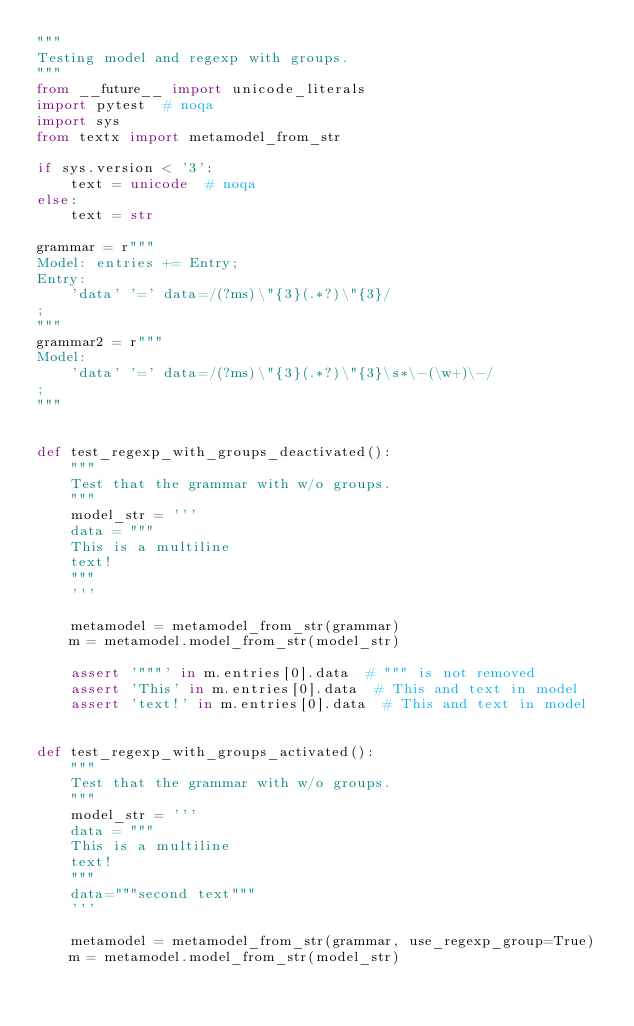Convert code to text. <code><loc_0><loc_0><loc_500><loc_500><_Python_>"""
Testing model and regexp with groups.
"""
from __future__ import unicode_literals
import pytest  # noqa
import sys
from textx import metamodel_from_str

if sys.version < '3':
    text = unicode  # noqa
else:
    text = str

grammar = r"""
Model: entries += Entry;
Entry:
    'data' '=' data=/(?ms)\"{3}(.*?)\"{3}/
;
"""
grammar2 = r"""
Model:
    'data' '=' data=/(?ms)\"{3}(.*?)\"{3}\s*\-(\w+)\-/
;
"""


def test_regexp_with_groups_deactivated():
    """
    Test that the grammar with w/o groups.
    """
    model_str = '''
    data = """
    This is a multiline
    text!
    """
    '''

    metamodel = metamodel_from_str(grammar)
    m = metamodel.model_from_str(model_str)

    assert '"""' in m.entries[0].data  # """ is not removed
    assert 'This' in m.entries[0].data  # This and text in model
    assert 'text!' in m.entries[0].data  # This and text in model


def test_regexp_with_groups_activated():
    """
    Test that the grammar with w/o groups.
    """
    model_str = '''
    data = """
    This is a multiline
    text!
    """
    data="""second text"""
    '''

    metamodel = metamodel_from_str(grammar, use_regexp_group=True)
    m = metamodel.model_from_str(model_str)
</code> 